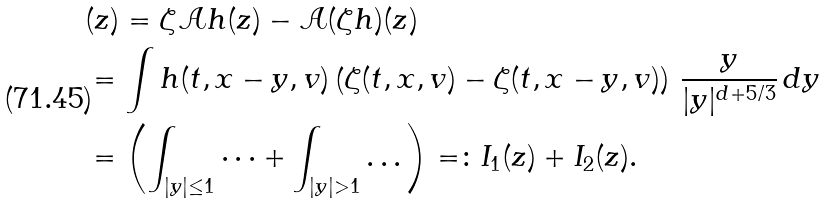Convert formula to latex. <formula><loc_0><loc_0><loc_500><loc_500>& ( z ) = \zeta \mathcal { A } h ( z ) - \mathcal { A } ( \zeta h ) ( z ) \\ & = \int h ( t , x - y , v ) \left ( \zeta ( t , x , v ) - \zeta ( t , x - y , v ) \right ) \, \frac { y } { | y | ^ { d + 5 / 3 } } \, d y \\ & = \left ( \int _ { | y | \leq 1 } \dots + \int _ { | y | > 1 } \dots \right ) = \colon I _ { 1 } ( z ) + I _ { 2 } ( z ) .</formula> 